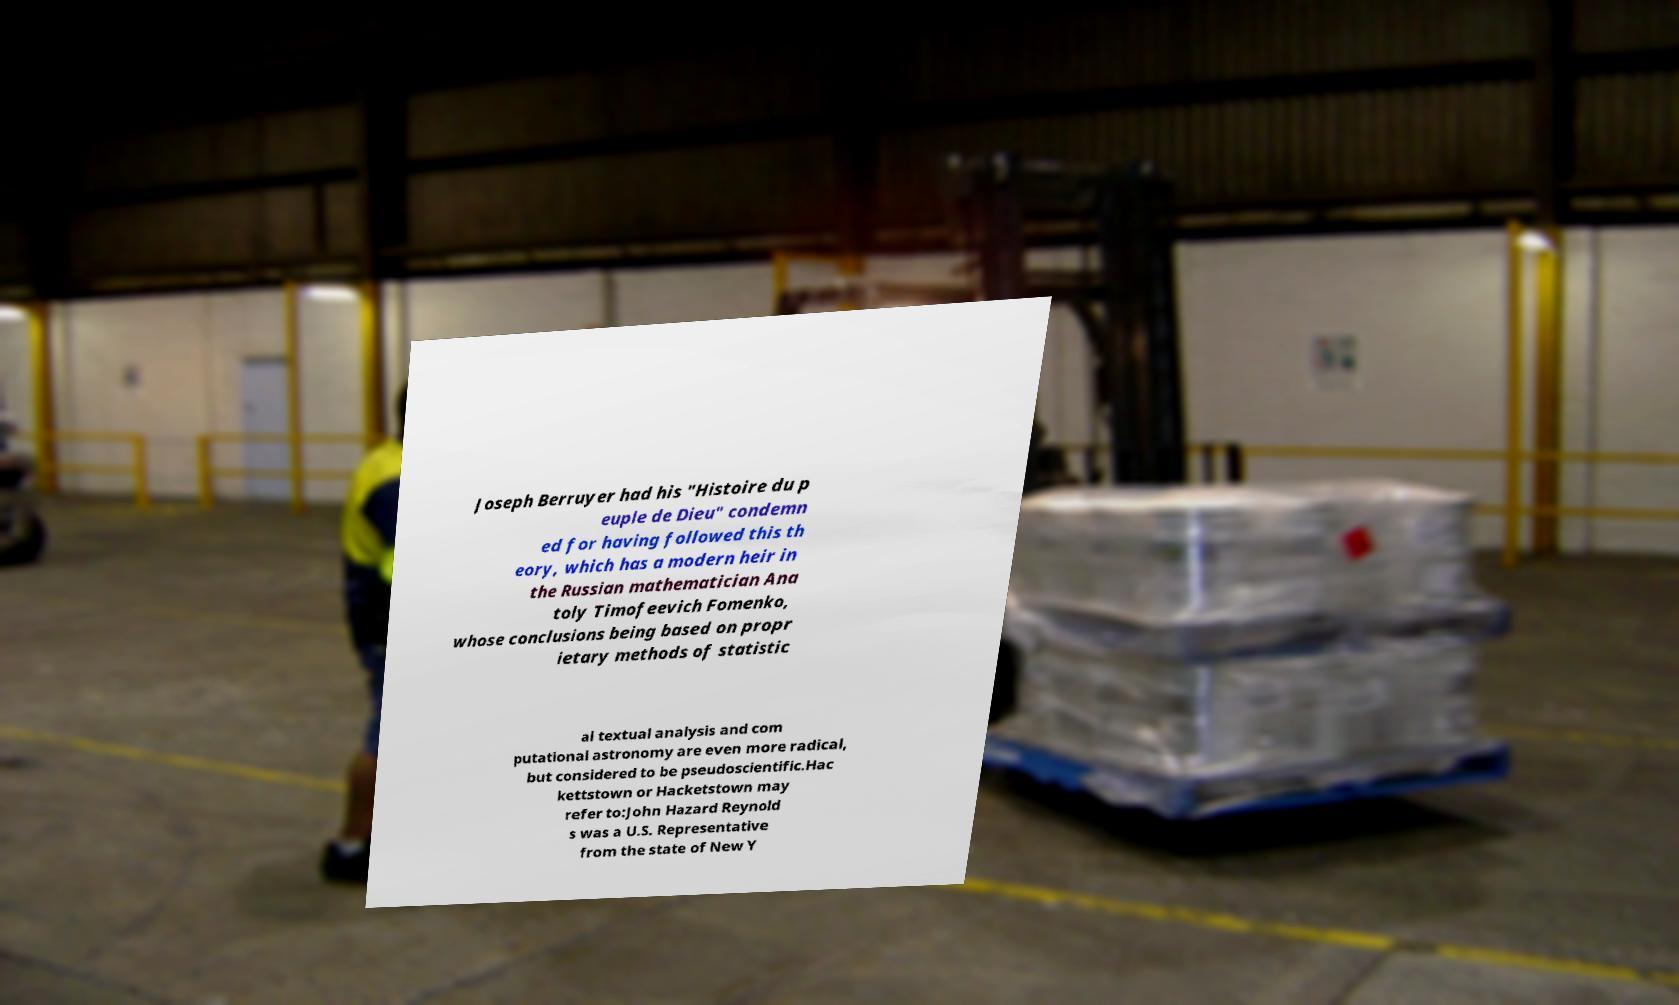Please identify and transcribe the text found in this image. Joseph Berruyer had his "Histoire du p euple de Dieu" condemn ed for having followed this th eory, which has a modern heir in the Russian mathematician Ana toly Timofeevich Fomenko, whose conclusions being based on propr ietary methods of statistic al textual analysis and com putational astronomy are even more radical, but considered to be pseudoscientific.Hac kettstown or Hacketstown may refer to:John Hazard Reynold s was a U.S. Representative from the state of New Y 